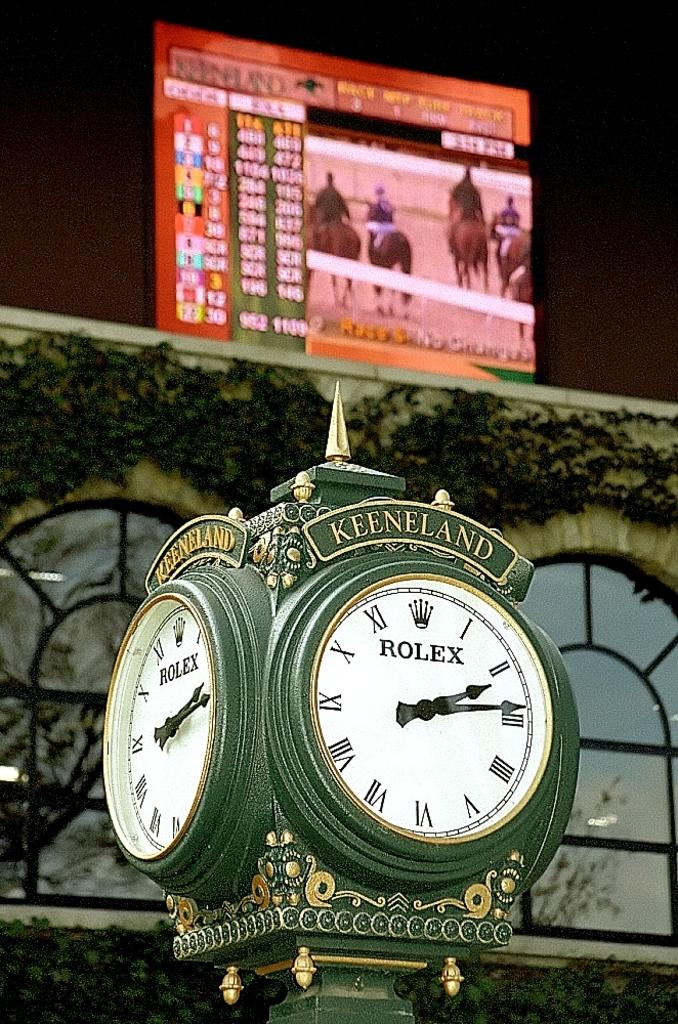<image>
Render a clear and concise summary of the photo. A green Rolex clock has Keeneland written on the top 